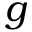Convert formula to latex. <formula><loc_0><loc_0><loc_500><loc_500>g</formula> 